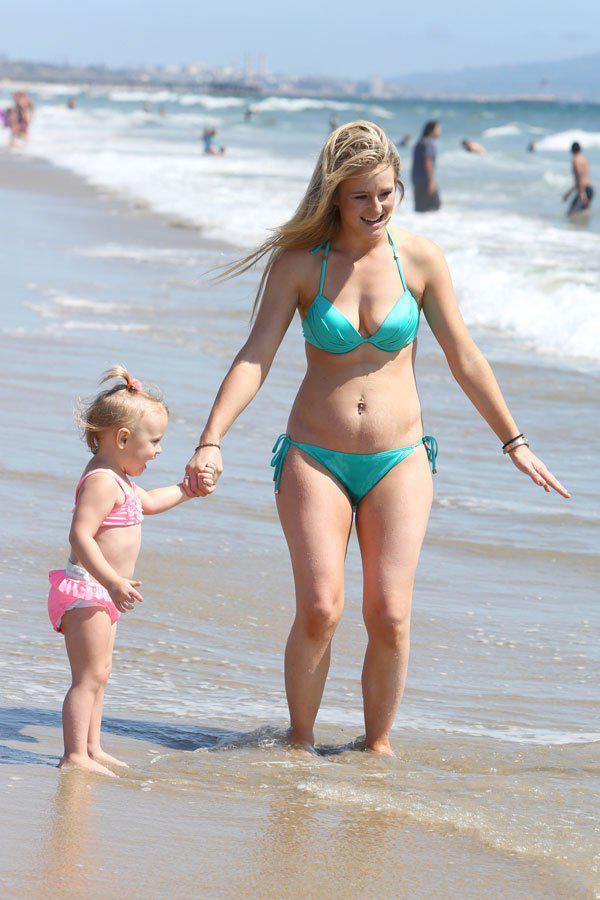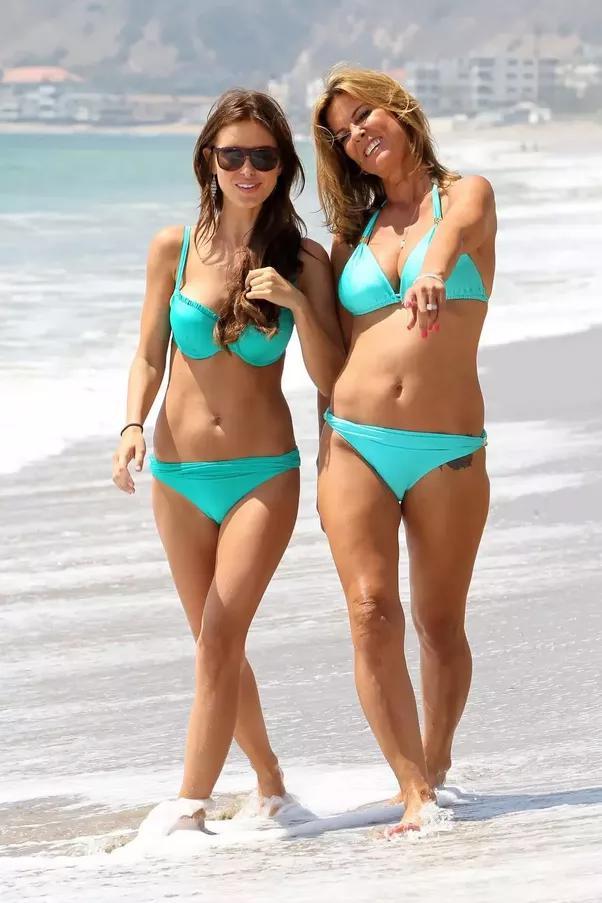The first image is the image on the left, the second image is the image on the right. Evaluate the accuracy of this statement regarding the images: "One image shows two women side by side modelling bikinis with similar colors.". Is it true? Answer yes or no. Yes. The first image is the image on the left, the second image is the image on the right. Considering the images on both sides, is "The combined images show four females in bikinis on the beach, and three bikini tops are the same solid color." valid? Answer yes or no. Yes. 